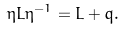Convert formula to latex. <formula><loc_0><loc_0><loc_500><loc_500>\eta L \eta ^ { - 1 } = L + q .</formula> 